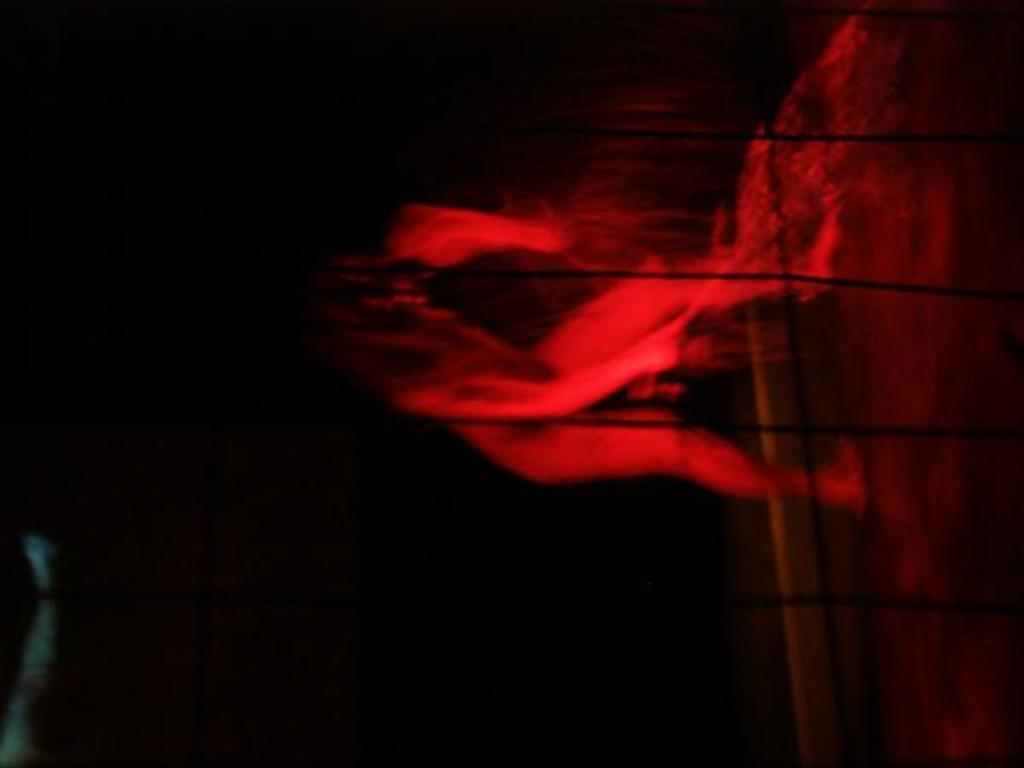What is the main subject of the image? There is a person in the image. What object is visible near the person? There is a microphone (mic) in the image. Can you describe the lighting in the image? The image is dark. What type of footwear is the person wearing in the image? There is no information about the person's footwear in the image, as it is not mentioned in the provided facts. --- Facts: 1. There is a car in the image. 2. The car is red. 3. The car has four wheels. 4. The car has a sunroof. Absurd Topics: bird Conversation: What is the main subject of the image? There is a car in the image. What color is the car? The car is red. How many wheels does the car have? The car has four wheels. What additional feature does the car have? The car has a sunroof. Reasoning: Let's think step by step in order to produce the conversation. We start by identifying the main subject of the image, which is the car. Next, we describe specific features of the car, such as its color and the number of wheels it has. Then, we mention any additional features that the car might have, in this case, a sunroof. Absurd Question/Answer: What type of bird can be seen sitting on the car's hood in the image? There are no birds present in the image. 